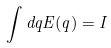Convert formula to latex. <formula><loc_0><loc_0><loc_500><loc_500>\int d q E ( q ) = I</formula> 